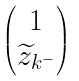<formula> <loc_0><loc_0><loc_500><loc_500>\begin{pmatrix} 1 \\ \widetilde { z } _ { k ^ { - } } \end{pmatrix}</formula> 